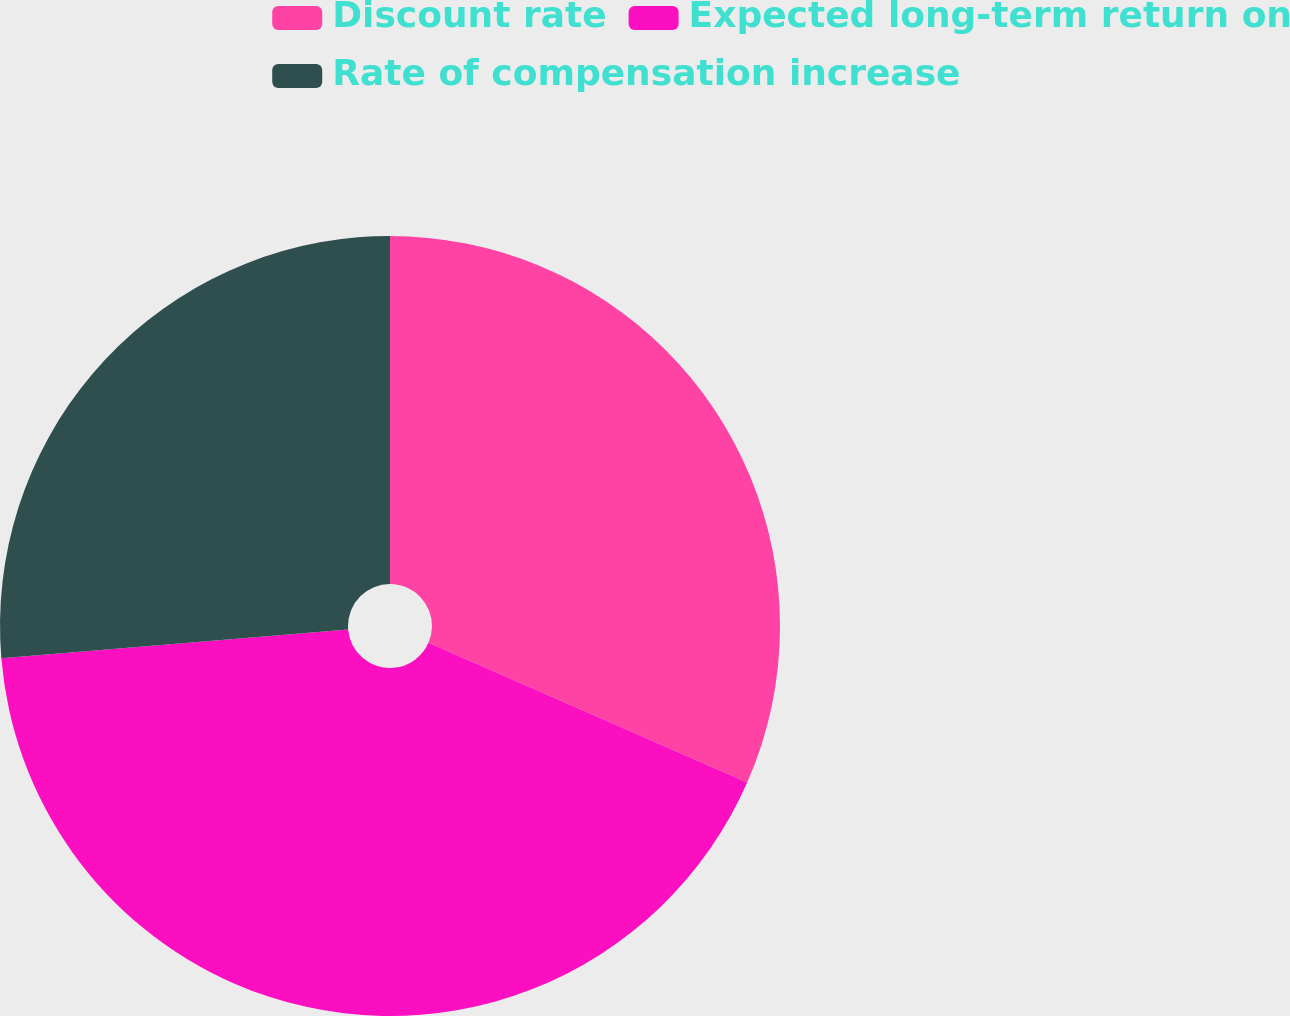Convert chart to OTSL. <chart><loc_0><loc_0><loc_500><loc_500><pie_chart><fcel>Discount rate<fcel>Expected long-term return on<fcel>Rate of compensation increase<nl><fcel>31.58%<fcel>42.11%<fcel>26.32%<nl></chart> 